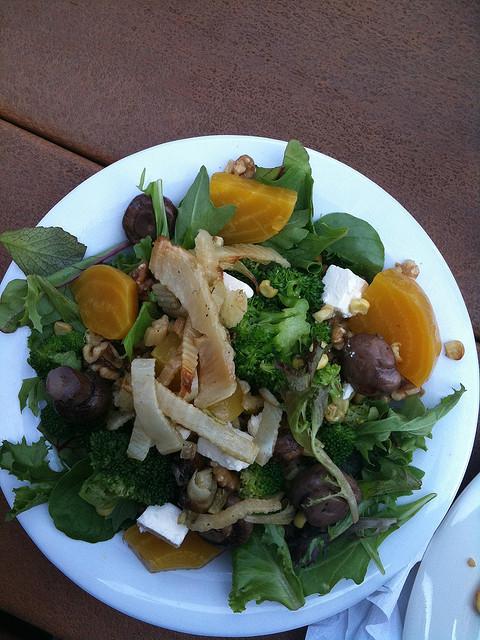What color is the plate?
Quick response, please. White. Do you see any red vegetables?
Answer briefly. No. Which fruit is shown here?
Keep it brief. Orange. Which are green?
Give a very brief answer. Lettuce. Will the broccoli be easy to eat without a knife?
Be succinct. Yes. Where are the beets?
Answer briefly. In salad. Is the plate round?
Write a very short answer. Yes. Has the food on this plate been placed randomly?
Answer briefly. Yes. What is mainly featured?
Short answer required. Salad. 